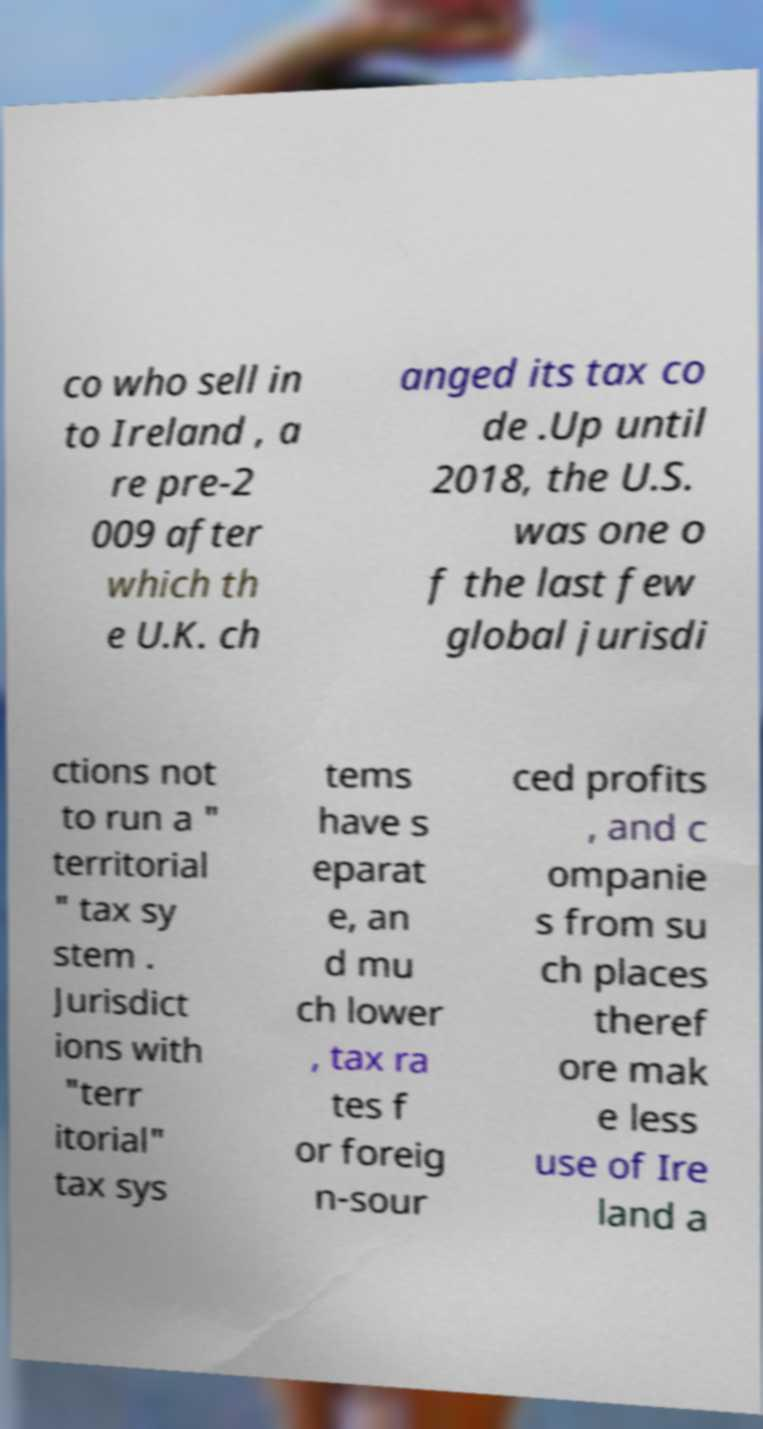Please read and relay the text visible in this image. What does it say? co who sell in to Ireland , a re pre-2 009 after which th e U.K. ch anged its tax co de .Up until 2018, the U.S. was one o f the last few global jurisdi ctions not to run a " territorial " tax sy stem . Jurisdict ions with "terr itorial" tax sys tems have s eparat e, an d mu ch lower , tax ra tes f or foreig n-sour ced profits , and c ompanie s from su ch places theref ore mak e less use of Ire land a 